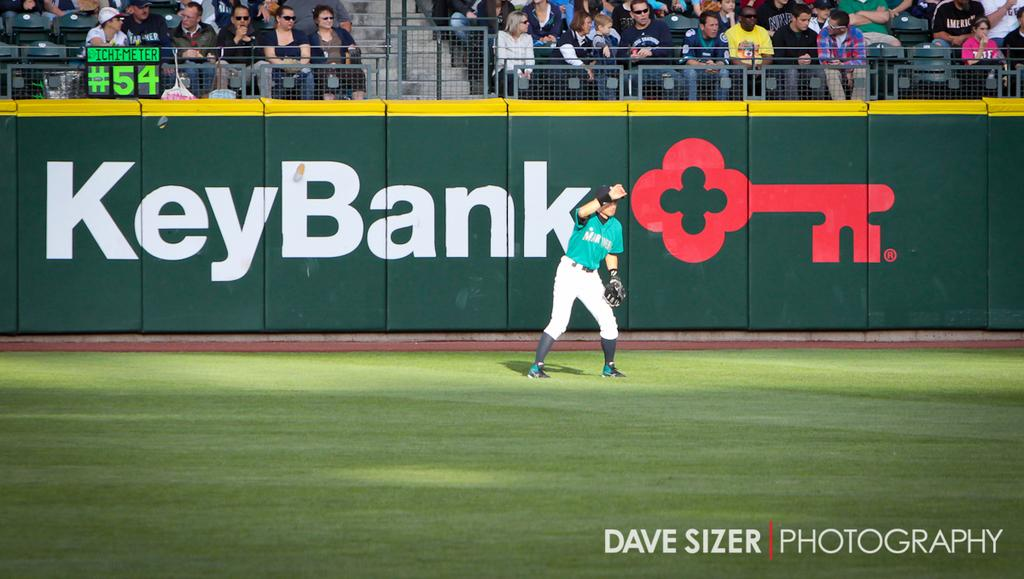<image>
Summarize the visual content of the image. An outfielder looks for the ball behind a banner that reads KeyBank. 